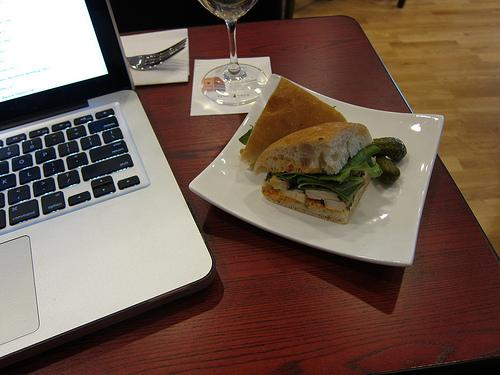Evaluate the overall quality of the image. The overall quality of the image is good, with clear descriptions of objects and their positions in a detailed manner. What aspects of the image show objects interacting with one another? Some of the interactions include the fork resting on the napkin, the sandwich placed on the plate, and the wine glass resting on a white paper. What is the main focus of this image? The main focus of the image is a sandwich on a square white plate, placed on a wooden table. Create a brief caption that represents the primary theme of the image. A tasty sandwich on a white plate, accompanied by a wine glass and silverware, set on a wooden table. How many objects on the table are related to food? There are seven food-related objects: a sandwich, a plate, a bun, mushroom and lettuce, baby gherkin pickles, a square white piece of paper (presumably as a napkin), and slices of chicken. Describe the color and style of the floors in the room. There are light wood pattern flooring and dark cherry wood look formica, as well as a light brown wood floor. Identify the utensils and other objects placed near the sandwich. A fork on a white napkin, a wine glass on a napkin, and baby gherkin pickles are placed near the sandwich. How many objects are clearly associated with a laptop computer, and what are they? There are five objects associated with a laptop computer: a white laptop computer, black buttons, a keyboard, a mouse pad area, and a screen area. What is the sentiment of the image, and why? The image has a positive sentiment, as it portrays lunchtime with a delicious-looking sandwich and a pleasant setting. Is the wine glass filled with red wine instead of water? The image describes "water in a wine glass," not red wine. Is the object on the floor a chair and not a wooden table? The image describes a "small mahogany dining table" and "wooden table with several items on it," not a chair. Does the sandwich contain slices of turkey instead of chicken? The image describes "slices of chicken on a sandwich," not turkey. Can you see a spoon lying on the white napkin? The image describes "a fork on a napkin," not a spoon. Is the floor in the image covered in green carpet? The image describes various instances of wooden floorings such as "light wood pattern flooring" and "dark cherry wood look formica," not a carpet. Is the laptop on the table pink in color? The laptop described in the image is a "white lap top computer" and a "silver colored laptop computer," not a pink one. 